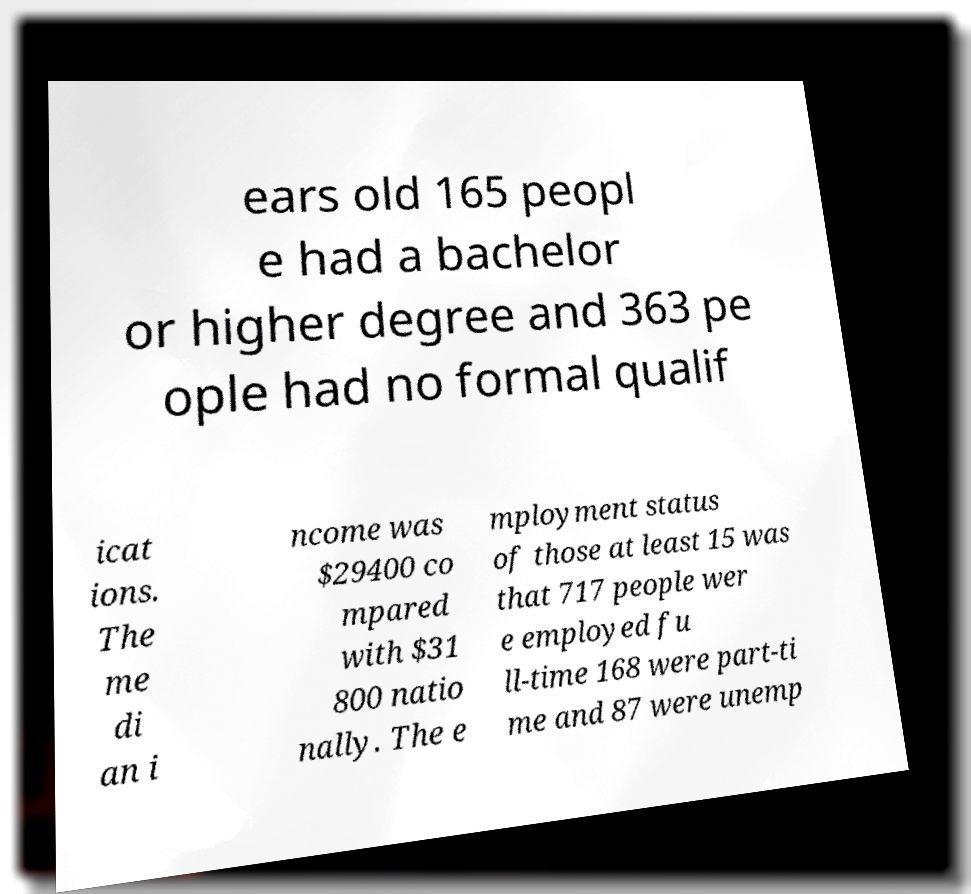Could you assist in decoding the text presented in this image and type it out clearly? ears old 165 peopl e had a bachelor or higher degree and 363 pe ople had no formal qualif icat ions. The me di an i ncome was $29400 co mpared with $31 800 natio nally. The e mployment status of those at least 15 was that 717 people wer e employed fu ll-time 168 were part-ti me and 87 were unemp 